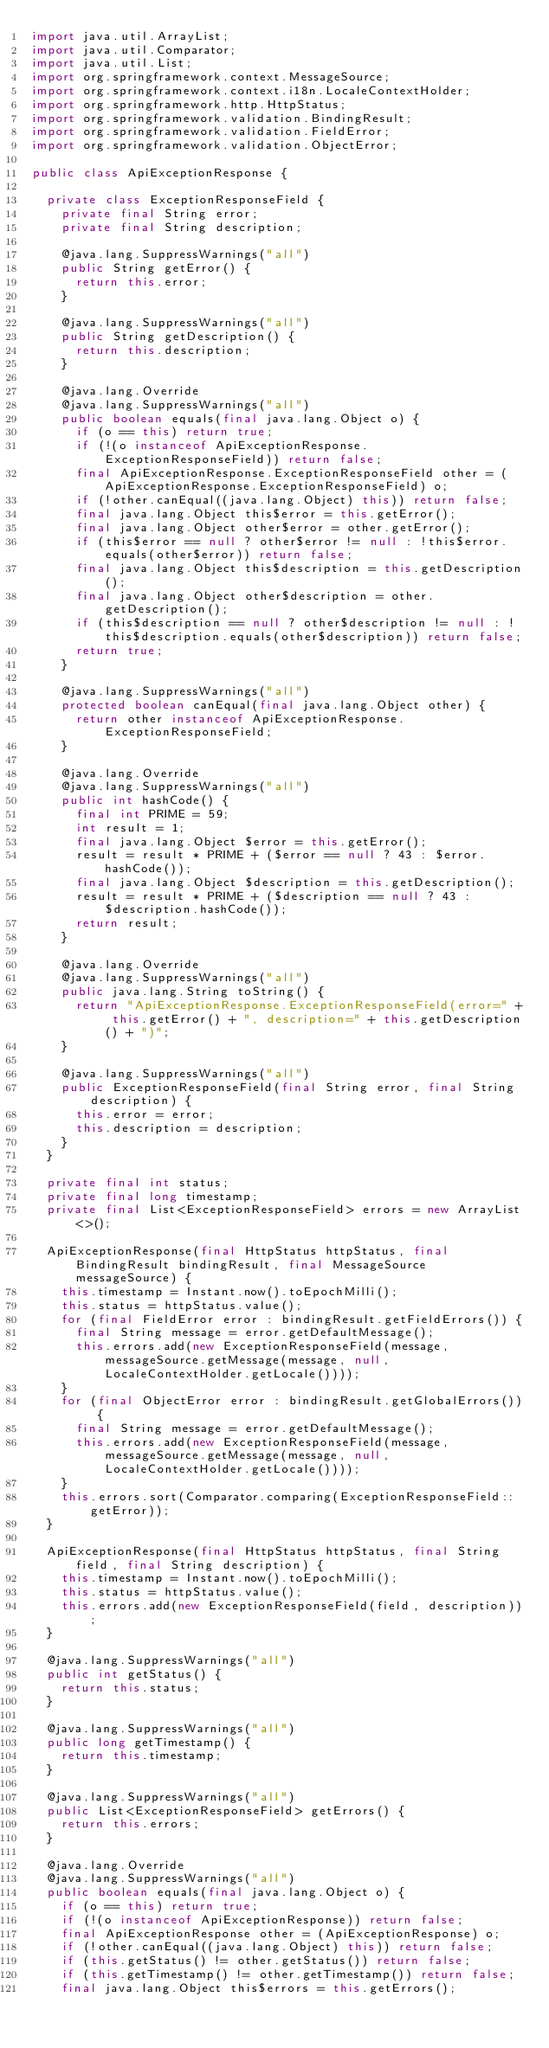<code> <loc_0><loc_0><loc_500><loc_500><_Java_>import java.util.ArrayList;
import java.util.Comparator;
import java.util.List;
import org.springframework.context.MessageSource;
import org.springframework.context.i18n.LocaleContextHolder;
import org.springframework.http.HttpStatus;
import org.springframework.validation.BindingResult;
import org.springframework.validation.FieldError;
import org.springframework.validation.ObjectError;

public class ApiExceptionResponse {

	private class ExceptionResponseField {
		private final String error;
		private final String description;

		@java.lang.SuppressWarnings("all")
		public String getError() {
			return this.error;
		}

		@java.lang.SuppressWarnings("all")
		public String getDescription() {
			return this.description;
		}

		@java.lang.Override
		@java.lang.SuppressWarnings("all")
		public boolean equals(final java.lang.Object o) {
			if (o == this) return true;
			if (!(o instanceof ApiExceptionResponse.ExceptionResponseField)) return false;
			final ApiExceptionResponse.ExceptionResponseField other = (ApiExceptionResponse.ExceptionResponseField) o;
			if (!other.canEqual((java.lang.Object) this)) return false;
			final java.lang.Object this$error = this.getError();
			final java.lang.Object other$error = other.getError();
			if (this$error == null ? other$error != null : !this$error.equals(other$error)) return false;
			final java.lang.Object this$description = this.getDescription();
			final java.lang.Object other$description = other.getDescription();
			if (this$description == null ? other$description != null : !this$description.equals(other$description)) return false;
			return true;
		}

		@java.lang.SuppressWarnings("all")
		protected boolean canEqual(final java.lang.Object other) {
			return other instanceof ApiExceptionResponse.ExceptionResponseField;
		}

		@java.lang.Override
		@java.lang.SuppressWarnings("all")
		public int hashCode() {
			final int PRIME = 59;
			int result = 1;
			final java.lang.Object $error = this.getError();
			result = result * PRIME + ($error == null ? 43 : $error.hashCode());
			final java.lang.Object $description = this.getDescription();
			result = result * PRIME + ($description == null ? 43 : $description.hashCode());
			return result;
		}

		@java.lang.Override
		@java.lang.SuppressWarnings("all")
		public java.lang.String toString() {
			return "ApiExceptionResponse.ExceptionResponseField(error=" + this.getError() + ", description=" + this.getDescription() + ")";
		}

		@java.lang.SuppressWarnings("all")
		public ExceptionResponseField(final String error, final String description) {
			this.error = error;
			this.description = description;
		}
	}

	private final int status;
	private final long timestamp;
	private final List<ExceptionResponseField> errors = new ArrayList<>();

	ApiExceptionResponse(final HttpStatus httpStatus, final BindingResult bindingResult, final MessageSource messageSource) {
		this.timestamp = Instant.now().toEpochMilli();
		this.status = httpStatus.value();
		for (final FieldError error : bindingResult.getFieldErrors()) {
			final String message = error.getDefaultMessage();
			this.errors.add(new ExceptionResponseField(message, messageSource.getMessage(message, null, LocaleContextHolder.getLocale())));
		}
		for (final ObjectError error : bindingResult.getGlobalErrors()) {
			final String message = error.getDefaultMessage();
			this.errors.add(new ExceptionResponseField(message, messageSource.getMessage(message, null, LocaleContextHolder.getLocale())));
		}
		this.errors.sort(Comparator.comparing(ExceptionResponseField::getError));
	}

	ApiExceptionResponse(final HttpStatus httpStatus, final String field, final String description) {
		this.timestamp = Instant.now().toEpochMilli();
		this.status = httpStatus.value();
		this.errors.add(new ExceptionResponseField(field, description));
	}

	@java.lang.SuppressWarnings("all")
	public int getStatus() {
		return this.status;
	}

	@java.lang.SuppressWarnings("all")
	public long getTimestamp() {
		return this.timestamp;
	}

	@java.lang.SuppressWarnings("all")
	public List<ExceptionResponseField> getErrors() {
		return this.errors;
	}

	@java.lang.Override
	@java.lang.SuppressWarnings("all")
	public boolean equals(final java.lang.Object o) {
		if (o == this) return true;
		if (!(o instanceof ApiExceptionResponse)) return false;
		final ApiExceptionResponse other = (ApiExceptionResponse) o;
		if (!other.canEqual((java.lang.Object) this)) return false;
		if (this.getStatus() != other.getStatus()) return false;
		if (this.getTimestamp() != other.getTimestamp()) return false;
		final java.lang.Object this$errors = this.getErrors();</code> 